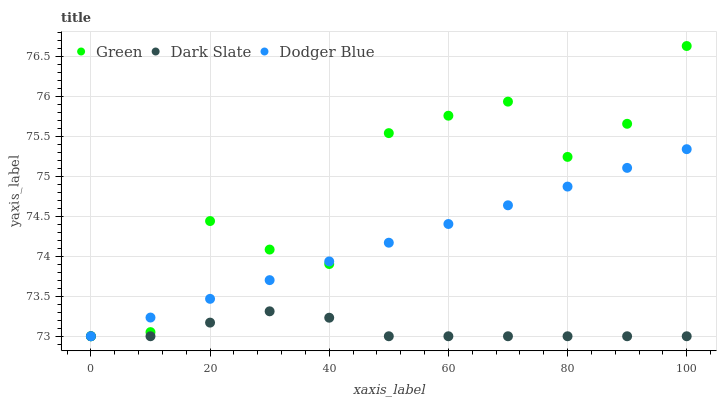Does Dark Slate have the minimum area under the curve?
Answer yes or no. Yes. Does Green have the maximum area under the curve?
Answer yes or no. Yes. Does Dodger Blue have the minimum area under the curve?
Answer yes or no. No. Does Dodger Blue have the maximum area under the curve?
Answer yes or no. No. Is Dodger Blue the smoothest?
Answer yes or no. Yes. Is Green the roughest?
Answer yes or no. Yes. Is Green the smoothest?
Answer yes or no. No. Is Dodger Blue the roughest?
Answer yes or no. No. Does Dark Slate have the lowest value?
Answer yes or no. Yes. Does Green have the highest value?
Answer yes or no. Yes. Does Dodger Blue have the highest value?
Answer yes or no. No. Does Green intersect Dark Slate?
Answer yes or no. Yes. Is Green less than Dark Slate?
Answer yes or no. No. Is Green greater than Dark Slate?
Answer yes or no. No. 